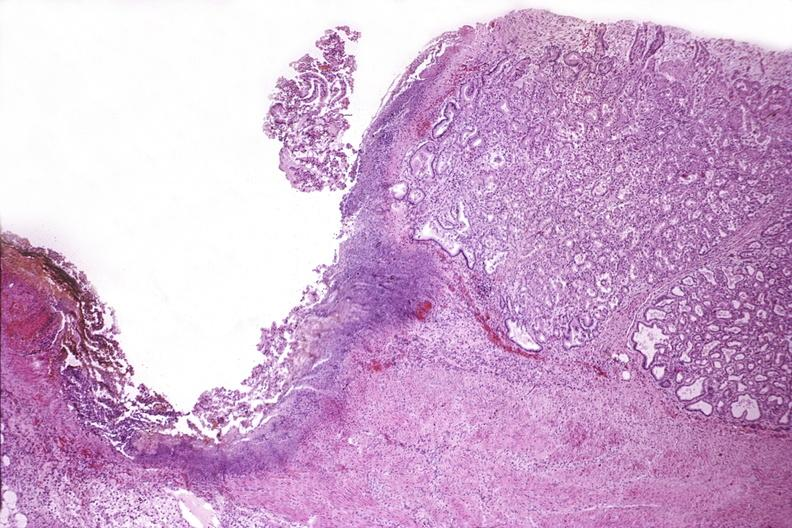what is present?
Answer the question using a single word or phrase. Gastrointestinal 